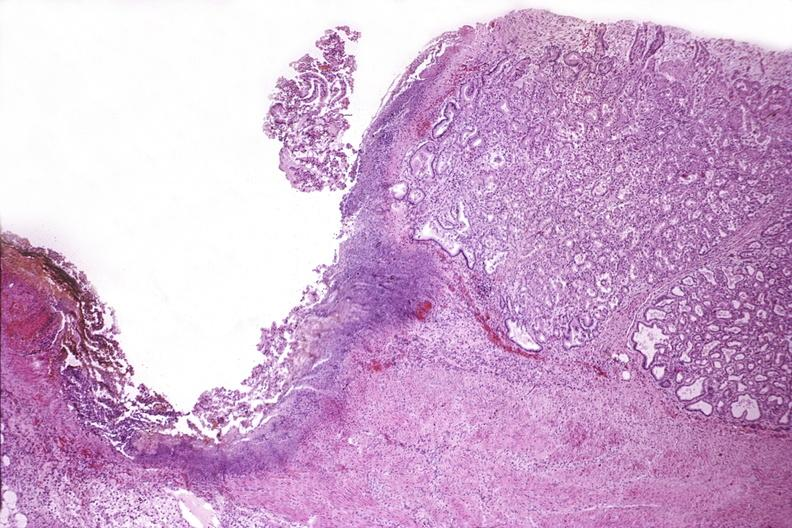what is present?
Answer the question using a single word or phrase. Gastrointestinal 